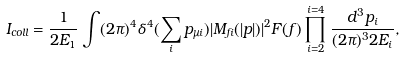<formula> <loc_0><loc_0><loc_500><loc_500>I _ { c o l l } = \frac { 1 } { 2 E _ { 1 } } \int ( 2 \pi ) ^ { 4 } \delta ^ { 4 } ( \sum _ { i } p _ { \mu i } ) | M _ { f i } ( | { p } | ) | ^ { 2 } F ( f ) \prod _ { i = 2 } ^ { i = 4 } \frac { d ^ { 3 } { p } _ { i } } { ( 2 \pi ) ^ { 3 } 2 E _ { i } } ,</formula> 